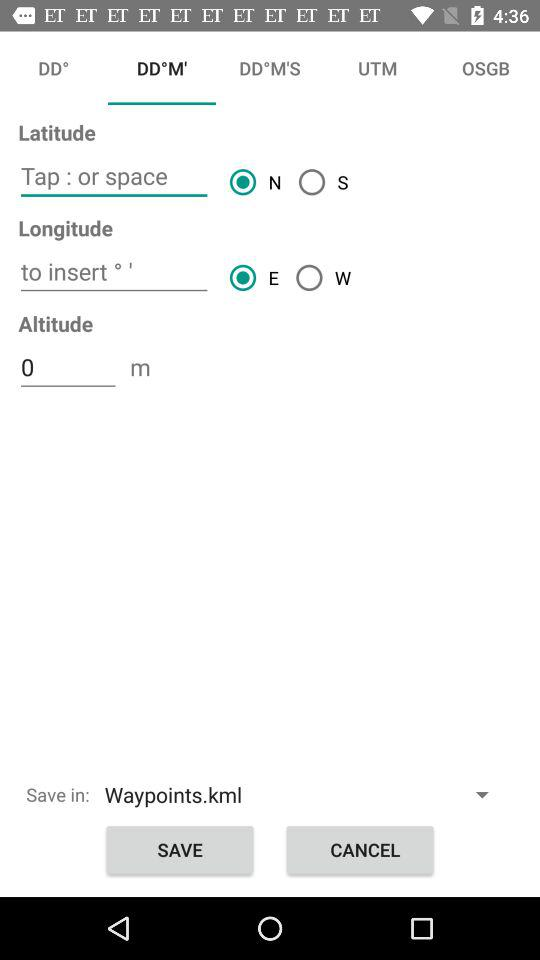Which tab is selected? The selected tab is "DD°M'". 